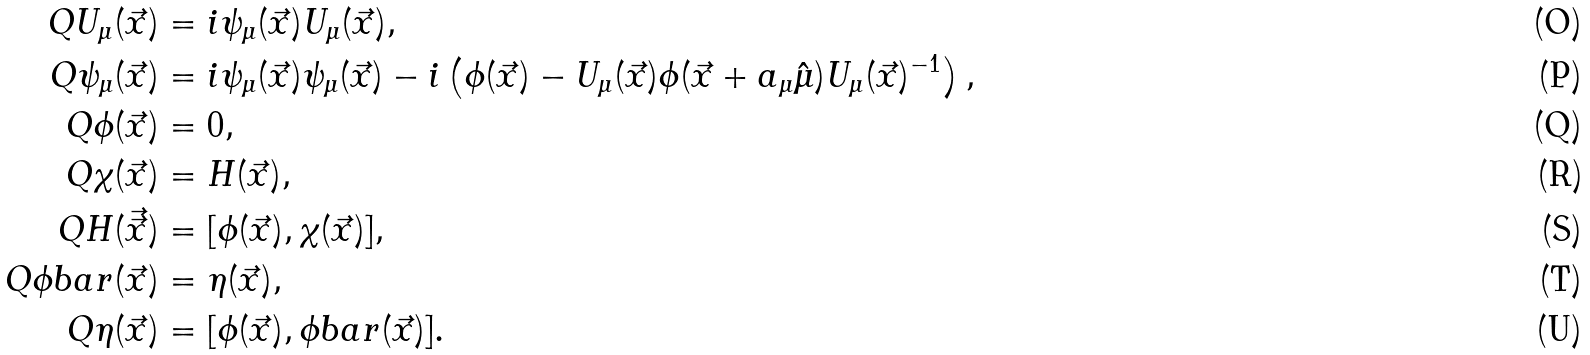<formula> <loc_0><loc_0><loc_500><loc_500>Q U _ { \mu } ( \vec { x } ) & = i \psi _ { \mu } ( \vec { x } ) U _ { \mu } ( \vec { x } ) , \\ Q \psi _ { \mu } ( \vec { x } ) & = i \psi _ { \mu } ( \vec { x } ) \psi _ { \mu } ( \vec { x } ) - i \left ( \phi ( \vec { x } ) - U _ { \mu } ( \vec { x } ) \phi ( \vec { x } + a _ { \mu } \hat { \mu } ) U _ { \mu } ( \vec { x } ) ^ { - 1 } \right ) , \\ Q \phi ( \vec { x } ) & = 0 , \\ Q \chi ( \vec { x } ) & = H ( \vec { x } ) , \\ Q H ( \vec { \vec { x } } ) & = [ \phi ( \vec { x } ) , \chi ( \vec { x } ) ] , \\ Q \phi b a r ( \vec { x } ) & = \eta ( \vec { x } ) , \\ Q \eta ( \vec { x } ) & = [ \phi ( \vec { x } ) , \phi b a r ( \vec { x } ) ] .</formula> 